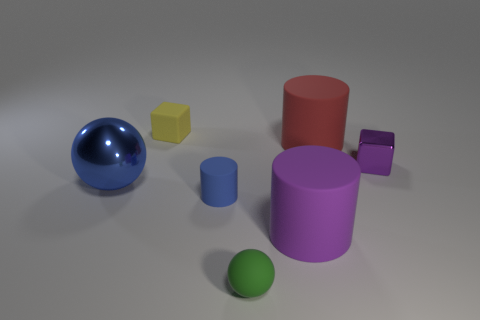There is a shiny thing that is to the left of the blue matte cylinder; what size is it?
Your answer should be compact. Large. There is a metal object that is left of the green rubber object; are there any large blue things that are behind it?
Your answer should be very brief. No. What number of other objects are the same shape as the red matte object?
Your answer should be compact. 2. Is the shape of the tiny purple object the same as the large purple matte object?
Keep it short and to the point. No. There is a small thing that is both behind the tiny blue cylinder and left of the big purple thing; what is its color?
Your response must be concise. Yellow. What size is the matte cylinder that is the same color as the shiny cube?
Offer a terse response. Large. How many small things are either cyan metal things or red rubber cylinders?
Ensure brevity in your answer.  0. Is there anything else of the same color as the tiny cylinder?
Provide a succinct answer. Yes. There is a big cylinder that is left of the cylinder behind the small cube that is on the right side of the small green matte object; what is it made of?
Ensure brevity in your answer.  Rubber. What number of rubber things are large purple things or tiny objects?
Make the answer very short. 4. 